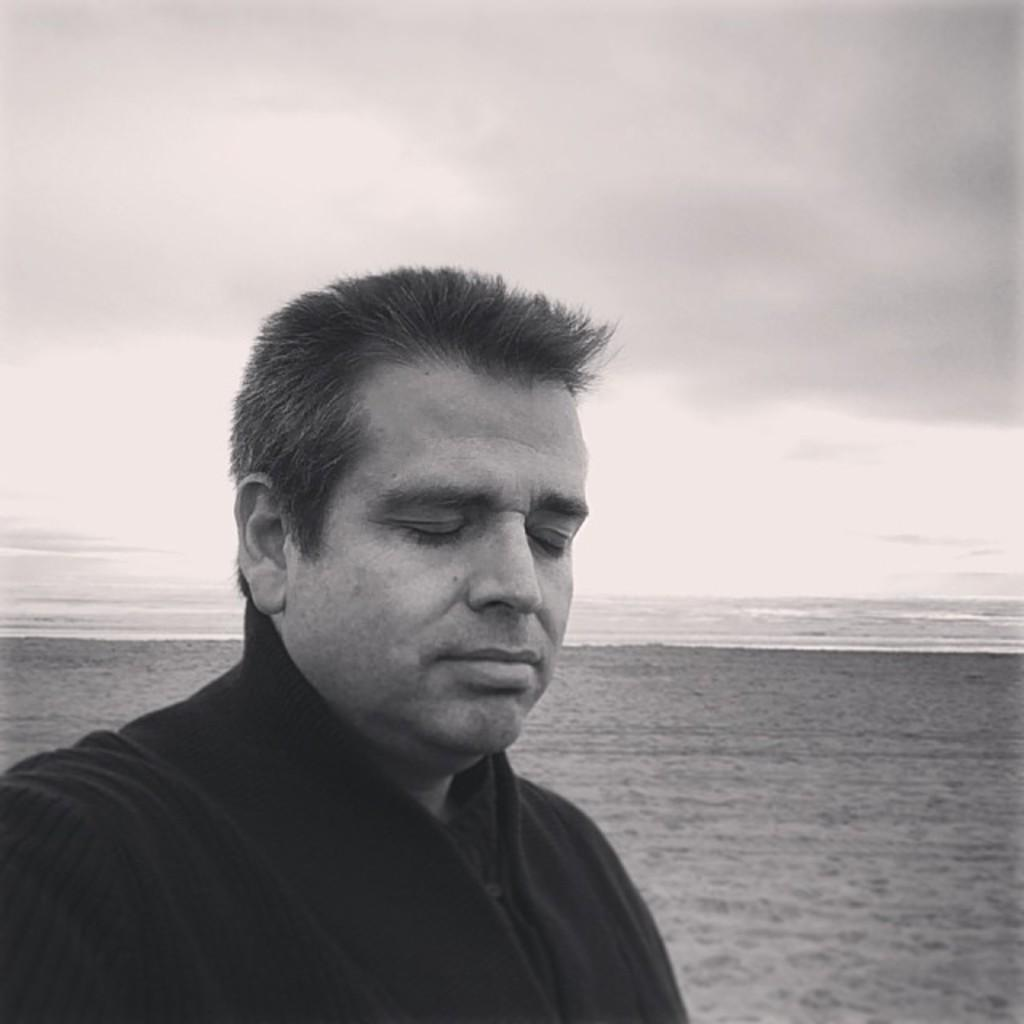What is the color scheme of the image? The image is black and white. Who or what can be seen in the image? There is a man in the image. What type of terrain is visible behind the man? There is sand on the ground behind the man. What is visible beyond the sand? There is water visible behind the sand. What is visible at the top of the image? The sky is visible at the top of the image. What type of disease is the man suffering from in the image? There is no indication of any disease in the image; it only shows a man standing on sand with water and sky visible in the background. 